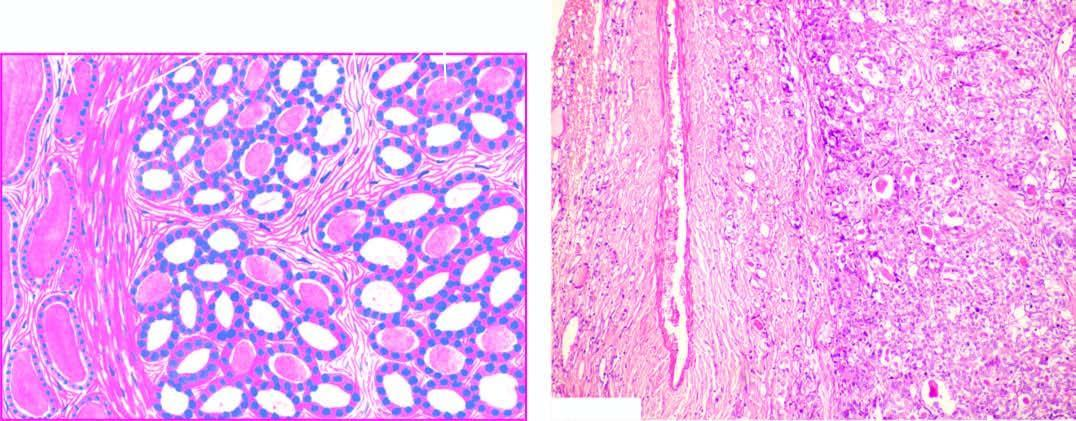what does the tumour consist of?
Answer the question using a single word or phrase. Small follicles lined by cuboidal epithelium and contain little or no colloid and separated by abundant loose stroma 